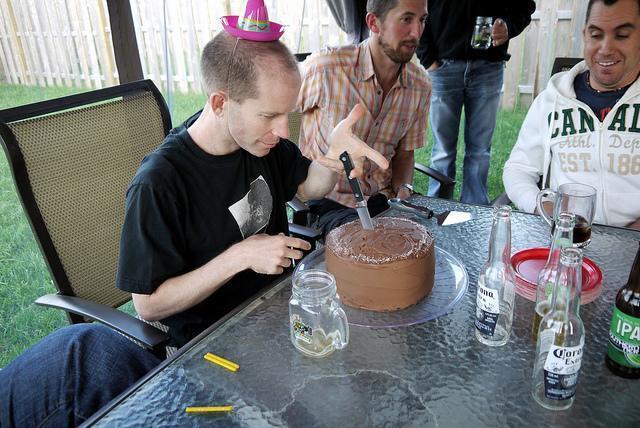How many people are there?
Give a very brief answer. 5. How many bottles are in the picture?
Give a very brief answer. 3. 